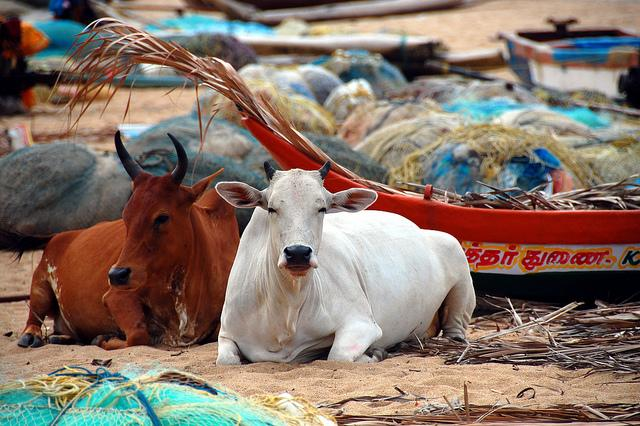What animal has similar things on their head to these animals?

Choices:
A) skunk
B) cat
C) dog
D) goat goat 